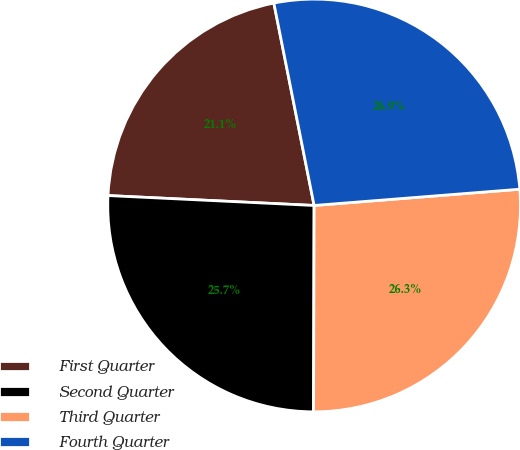Convert chart. <chart><loc_0><loc_0><loc_500><loc_500><pie_chart><fcel>First Quarter<fcel>Second Quarter<fcel>Third Quarter<fcel>Fourth Quarter<nl><fcel>21.11%<fcel>25.72%<fcel>26.3%<fcel>26.87%<nl></chart> 